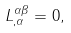Convert formula to latex. <formula><loc_0><loc_0><loc_500><loc_500>L _ { , \alpha } ^ { \alpha \beta } = 0 ,</formula> 